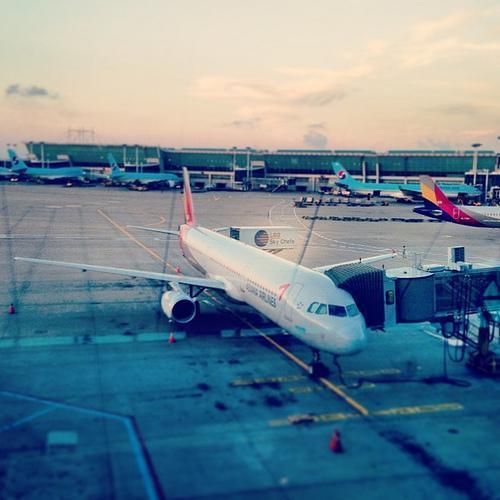How many white planes are there?
Give a very brief answer. 1. 